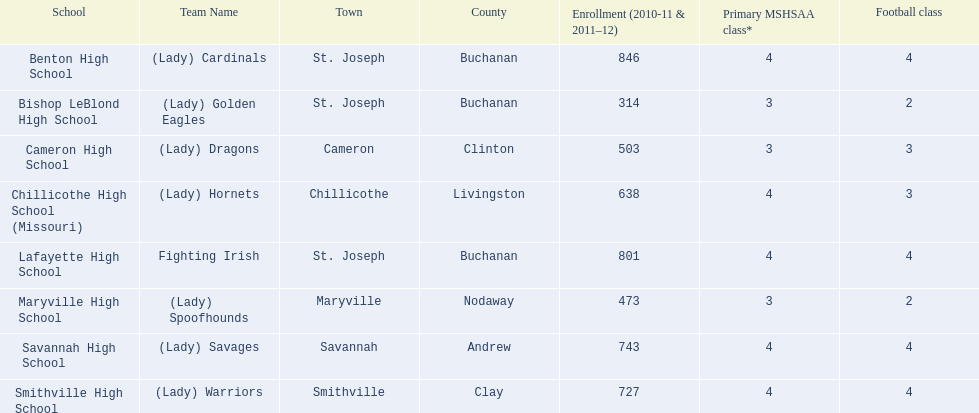Could you parse the entire table? {'header': ['School', 'Team Name', 'Town', 'County', 'Enrollment (2010-11 & 2011–12)', 'Primary MSHSAA class*', 'Football class'], 'rows': [['Benton High School', '(Lady) Cardinals', 'St. Joseph', 'Buchanan', '846', '4', '4'], ['Bishop LeBlond High School', '(Lady) Golden Eagles', 'St. Joseph', 'Buchanan', '314', '3', '2'], ['Cameron High School', '(Lady) Dragons', 'Cameron', 'Clinton', '503', '3', '3'], ['Chillicothe High School (Missouri)', '(Lady) Hornets', 'Chillicothe', 'Livingston', '638', '4', '3'], ['Lafayette High School', 'Fighting Irish', 'St. Joseph', 'Buchanan', '801', '4', '4'], ['Maryville High School', '(Lady) Spoofhounds', 'Maryville', 'Nodaway', '473', '3', '2'], ['Savannah High School', '(Lady) Savages', 'Savannah', 'Andrew', '743', '4', '4'], ['Smithville High School', '(Lady) Warriors', 'Smithville', 'Clay', '727', '4', '4']]} Can you provide the names of the schools? Benton High School, Bishop LeBlond High School, Cameron High School, Chillicothe High School (Missouri), Lafayette High School, Maryville High School, Savannah High School, Smithville High School. Of these schools, which ones have less than 500 enrolled students? Bishop LeBlond High School, Maryville High School. And from those, which school has the lowest enrollment? Bishop LeBlond High School. 